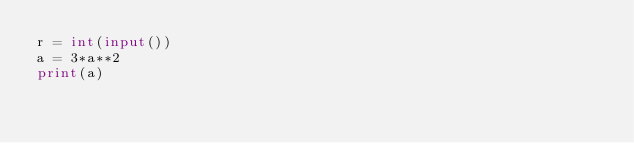Convert code to text. <code><loc_0><loc_0><loc_500><loc_500><_Python_>r = int(input())
a = 3*a**2
print(a)</code> 